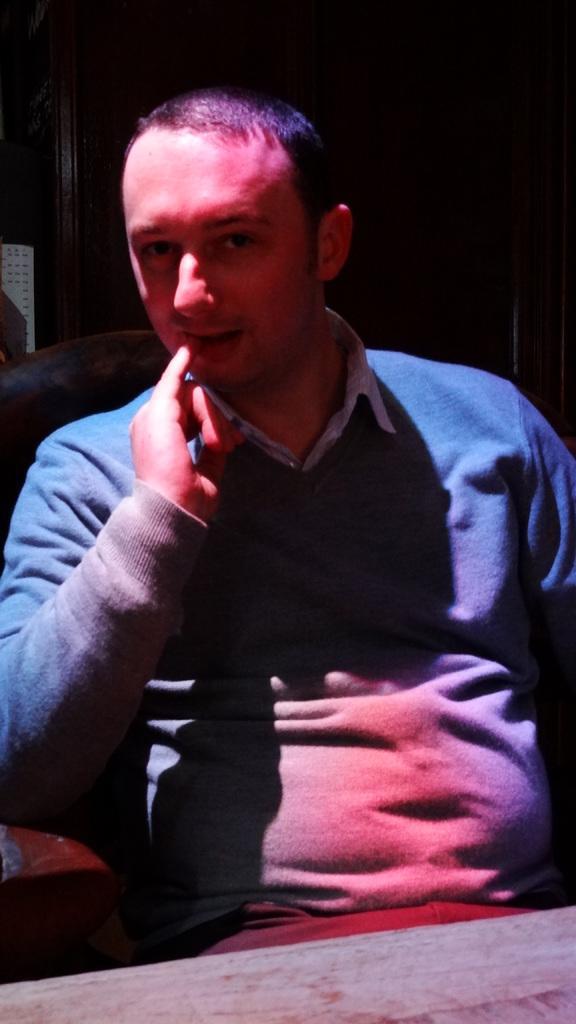How would you summarize this image in a sentence or two? In the center of the image there is a person wearing a sweater sitting on a chair. In front of him there is a table. 